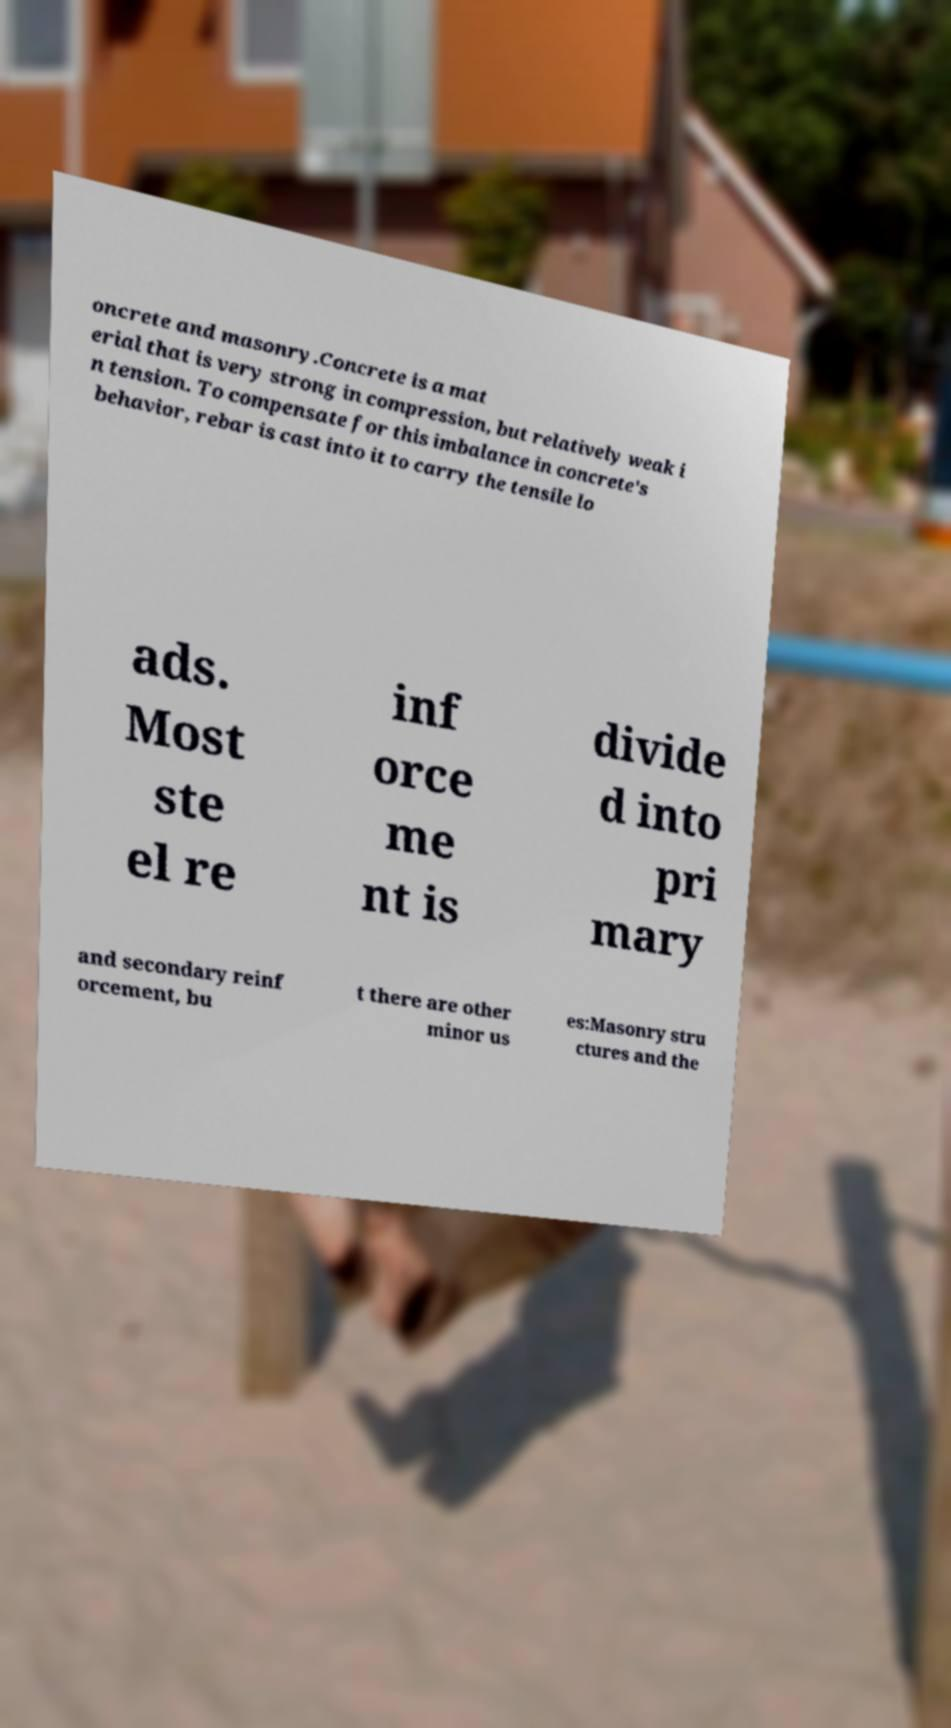There's text embedded in this image that I need extracted. Can you transcribe it verbatim? oncrete and masonry.Concrete is a mat erial that is very strong in compression, but relatively weak i n tension. To compensate for this imbalance in concrete's behavior, rebar is cast into it to carry the tensile lo ads. Most ste el re inf orce me nt is divide d into pri mary and secondary reinf orcement, bu t there are other minor us es:Masonry stru ctures and the 